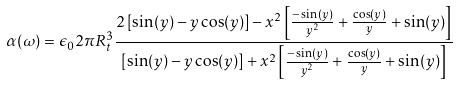Convert formula to latex. <formula><loc_0><loc_0><loc_500><loc_500>\alpha ( \omega ) = \epsilon _ { 0 } 2 \pi R _ { t } ^ { 3 } \frac { 2 \left [ \sin ( y ) - y \cos ( y ) \right ] - x ^ { 2 } \left [ \frac { - \sin ( y ) } { y ^ { 2 } } + \frac { \cos ( y ) } { y } + \sin ( y ) \right ] } { \left [ \sin ( y ) - y \cos ( y ) \right ] + x ^ { 2 } \left [ \frac { - \sin ( y ) } { y ^ { 2 } } + \frac { \cos ( y ) } { y } + \sin ( y ) \right ] }</formula> 